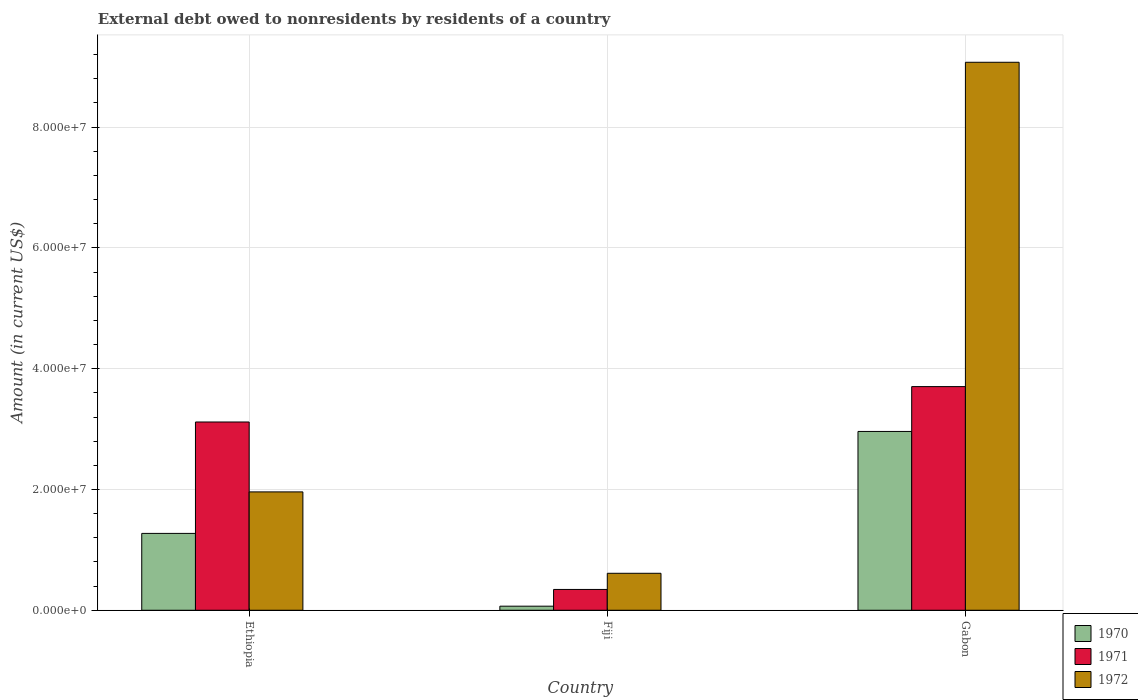How many groups of bars are there?
Your answer should be compact. 3. What is the label of the 2nd group of bars from the left?
Offer a very short reply. Fiji. What is the external debt owed by residents in 1971 in Ethiopia?
Keep it short and to the point. 3.12e+07. Across all countries, what is the maximum external debt owed by residents in 1971?
Offer a terse response. 3.70e+07. Across all countries, what is the minimum external debt owed by residents in 1972?
Keep it short and to the point. 6.12e+06. In which country was the external debt owed by residents in 1971 maximum?
Keep it short and to the point. Gabon. In which country was the external debt owed by residents in 1970 minimum?
Your response must be concise. Fiji. What is the total external debt owed by residents in 1971 in the graph?
Your answer should be very brief. 7.17e+07. What is the difference between the external debt owed by residents in 1970 in Fiji and that in Gabon?
Your response must be concise. -2.89e+07. What is the difference between the external debt owed by residents in 1971 in Gabon and the external debt owed by residents in 1972 in Ethiopia?
Ensure brevity in your answer.  1.74e+07. What is the average external debt owed by residents in 1972 per country?
Make the answer very short. 3.88e+07. What is the difference between the external debt owed by residents of/in 1971 and external debt owed by residents of/in 1970 in Ethiopia?
Offer a very short reply. 1.84e+07. What is the ratio of the external debt owed by residents in 1970 in Ethiopia to that in Fiji?
Keep it short and to the point. 18.8. Is the external debt owed by residents in 1972 in Fiji less than that in Gabon?
Give a very brief answer. Yes. What is the difference between the highest and the second highest external debt owed by residents in 1971?
Keep it short and to the point. 5.86e+06. What is the difference between the highest and the lowest external debt owed by residents in 1972?
Make the answer very short. 8.46e+07. Is it the case that in every country, the sum of the external debt owed by residents in 1970 and external debt owed by residents in 1972 is greater than the external debt owed by residents in 1971?
Make the answer very short. Yes. Are all the bars in the graph horizontal?
Ensure brevity in your answer.  No. How many countries are there in the graph?
Provide a succinct answer. 3. Does the graph contain any zero values?
Give a very brief answer. No. Does the graph contain grids?
Your answer should be very brief. Yes. Where does the legend appear in the graph?
Your answer should be compact. Bottom right. How many legend labels are there?
Give a very brief answer. 3. What is the title of the graph?
Your response must be concise. External debt owed to nonresidents by residents of a country. Does "1972" appear as one of the legend labels in the graph?
Your answer should be very brief. Yes. What is the Amount (in current US$) in 1970 in Ethiopia?
Give a very brief answer. 1.27e+07. What is the Amount (in current US$) in 1971 in Ethiopia?
Offer a very short reply. 3.12e+07. What is the Amount (in current US$) in 1972 in Ethiopia?
Your response must be concise. 1.96e+07. What is the Amount (in current US$) in 1970 in Fiji?
Your answer should be compact. 6.77e+05. What is the Amount (in current US$) in 1971 in Fiji?
Your answer should be compact. 3.45e+06. What is the Amount (in current US$) in 1972 in Fiji?
Offer a terse response. 6.12e+06. What is the Amount (in current US$) in 1970 in Gabon?
Your response must be concise. 2.96e+07. What is the Amount (in current US$) in 1971 in Gabon?
Give a very brief answer. 3.70e+07. What is the Amount (in current US$) in 1972 in Gabon?
Your answer should be compact. 9.07e+07. Across all countries, what is the maximum Amount (in current US$) of 1970?
Provide a short and direct response. 2.96e+07. Across all countries, what is the maximum Amount (in current US$) of 1971?
Your answer should be very brief. 3.70e+07. Across all countries, what is the maximum Amount (in current US$) of 1972?
Make the answer very short. 9.07e+07. Across all countries, what is the minimum Amount (in current US$) of 1970?
Offer a terse response. 6.77e+05. Across all countries, what is the minimum Amount (in current US$) of 1971?
Give a very brief answer. 3.45e+06. Across all countries, what is the minimum Amount (in current US$) in 1972?
Your answer should be compact. 6.12e+06. What is the total Amount (in current US$) of 1970 in the graph?
Your answer should be compact. 4.30e+07. What is the total Amount (in current US$) of 1971 in the graph?
Your answer should be compact. 7.17e+07. What is the total Amount (in current US$) of 1972 in the graph?
Provide a short and direct response. 1.16e+08. What is the difference between the Amount (in current US$) of 1970 in Ethiopia and that in Fiji?
Provide a succinct answer. 1.20e+07. What is the difference between the Amount (in current US$) of 1971 in Ethiopia and that in Fiji?
Offer a very short reply. 2.77e+07. What is the difference between the Amount (in current US$) of 1972 in Ethiopia and that in Fiji?
Your answer should be compact. 1.35e+07. What is the difference between the Amount (in current US$) of 1970 in Ethiopia and that in Gabon?
Give a very brief answer. -1.69e+07. What is the difference between the Amount (in current US$) of 1971 in Ethiopia and that in Gabon?
Your answer should be very brief. -5.86e+06. What is the difference between the Amount (in current US$) of 1972 in Ethiopia and that in Gabon?
Give a very brief answer. -7.11e+07. What is the difference between the Amount (in current US$) of 1970 in Fiji and that in Gabon?
Offer a very short reply. -2.89e+07. What is the difference between the Amount (in current US$) of 1971 in Fiji and that in Gabon?
Keep it short and to the point. -3.36e+07. What is the difference between the Amount (in current US$) of 1972 in Fiji and that in Gabon?
Provide a short and direct response. -8.46e+07. What is the difference between the Amount (in current US$) in 1970 in Ethiopia and the Amount (in current US$) in 1971 in Fiji?
Give a very brief answer. 9.28e+06. What is the difference between the Amount (in current US$) in 1970 in Ethiopia and the Amount (in current US$) in 1972 in Fiji?
Ensure brevity in your answer.  6.61e+06. What is the difference between the Amount (in current US$) of 1971 in Ethiopia and the Amount (in current US$) of 1972 in Fiji?
Your response must be concise. 2.51e+07. What is the difference between the Amount (in current US$) of 1970 in Ethiopia and the Amount (in current US$) of 1971 in Gabon?
Keep it short and to the point. -2.43e+07. What is the difference between the Amount (in current US$) of 1970 in Ethiopia and the Amount (in current US$) of 1972 in Gabon?
Give a very brief answer. -7.80e+07. What is the difference between the Amount (in current US$) in 1971 in Ethiopia and the Amount (in current US$) in 1972 in Gabon?
Offer a terse response. -5.96e+07. What is the difference between the Amount (in current US$) of 1970 in Fiji and the Amount (in current US$) of 1971 in Gabon?
Your response must be concise. -3.64e+07. What is the difference between the Amount (in current US$) of 1970 in Fiji and the Amount (in current US$) of 1972 in Gabon?
Give a very brief answer. -9.01e+07. What is the difference between the Amount (in current US$) of 1971 in Fiji and the Amount (in current US$) of 1972 in Gabon?
Keep it short and to the point. -8.73e+07. What is the average Amount (in current US$) in 1970 per country?
Give a very brief answer. 1.43e+07. What is the average Amount (in current US$) in 1971 per country?
Your response must be concise. 2.39e+07. What is the average Amount (in current US$) of 1972 per country?
Offer a very short reply. 3.88e+07. What is the difference between the Amount (in current US$) in 1970 and Amount (in current US$) in 1971 in Ethiopia?
Offer a terse response. -1.84e+07. What is the difference between the Amount (in current US$) in 1970 and Amount (in current US$) in 1972 in Ethiopia?
Provide a succinct answer. -6.87e+06. What is the difference between the Amount (in current US$) in 1971 and Amount (in current US$) in 1972 in Ethiopia?
Provide a succinct answer. 1.16e+07. What is the difference between the Amount (in current US$) of 1970 and Amount (in current US$) of 1971 in Fiji?
Make the answer very short. -2.77e+06. What is the difference between the Amount (in current US$) in 1970 and Amount (in current US$) in 1972 in Fiji?
Your answer should be very brief. -5.44e+06. What is the difference between the Amount (in current US$) of 1971 and Amount (in current US$) of 1972 in Fiji?
Your response must be concise. -2.68e+06. What is the difference between the Amount (in current US$) in 1970 and Amount (in current US$) in 1971 in Gabon?
Ensure brevity in your answer.  -7.42e+06. What is the difference between the Amount (in current US$) in 1970 and Amount (in current US$) in 1972 in Gabon?
Give a very brief answer. -6.11e+07. What is the difference between the Amount (in current US$) of 1971 and Amount (in current US$) of 1972 in Gabon?
Ensure brevity in your answer.  -5.37e+07. What is the ratio of the Amount (in current US$) in 1970 in Ethiopia to that in Fiji?
Ensure brevity in your answer.  18.8. What is the ratio of the Amount (in current US$) of 1971 in Ethiopia to that in Fiji?
Keep it short and to the point. 9.05. What is the ratio of the Amount (in current US$) of 1972 in Ethiopia to that in Fiji?
Offer a very short reply. 3.2. What is the ratio of the Amount (in current US$) in 1970 in Ethiopia to that in Gabon?
Your answer should be very brief. 0.43. What is the ratio of the Amount (in current US$) of 1971 in Ethiopia to that in Gabon?
Give a very brief answer. 0.84. What is the ratio of the Amount (in current US$) of 1972 in Ethiopia to that in Gabon?
Keep it short and to the point. 0.22. What is the ratio of the Amount (in current US$) of 1970 in Fiji to that in Gabon?
Your answer should be compact. 0.02. What is the ratio of the Amount (in current US$) in 1971 in Fiji to that in Gabon?
Offer a terse response. 0.09. What is the ratio of the Amount (in current US$) of 1972 in Fiji to that in Gabon?
Offer a terse response. 0.07. What is the difference between the highest and the second highest Amount (in current US$) in 1970?
Ensure brevity in your answer.  1.69e+07. What is the difference between the highest and the second highest Amount (in current US$) of 1971?
Provide a short and direct response. 5.86e+06. What is the difference between the highest and the second highest Amount (in current US$) of 1972?
Your answer should be very brief. 7.11e+07. What is the difference between the highest and the lowest Amount (in current US$) in 1970?
Give a very brief answer. 2.89e+07. What is the difference between the highest and the lowest Amount (in current US$) of 1971?
Your response must be concise. 3.36e+07. What is the difference between the highest and the lowest Amount (in current US$) of 1972?
Ensure brevity in your answer.  8.46e+07. 